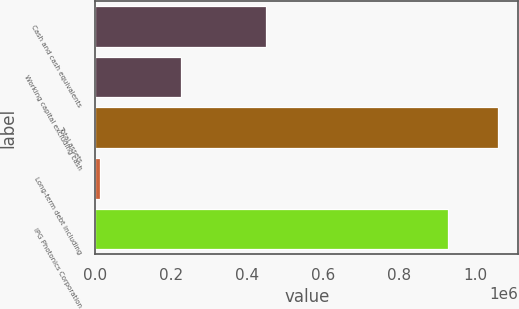Convert chart to OTSL. <chart><loc_0><loc_0><loc_500><loc_500><bar_chart><fcel>Cash and cash equivalents<fcel>Working capital excluding cash<fcel>Total assets<fcel>Long-term debt including<fcel>IPG Photonics Corporation<nl><fcel>448776<fcel>225365<fcel>1.06122e+06<fcel>12666<fcel>927969<nl></chart> 